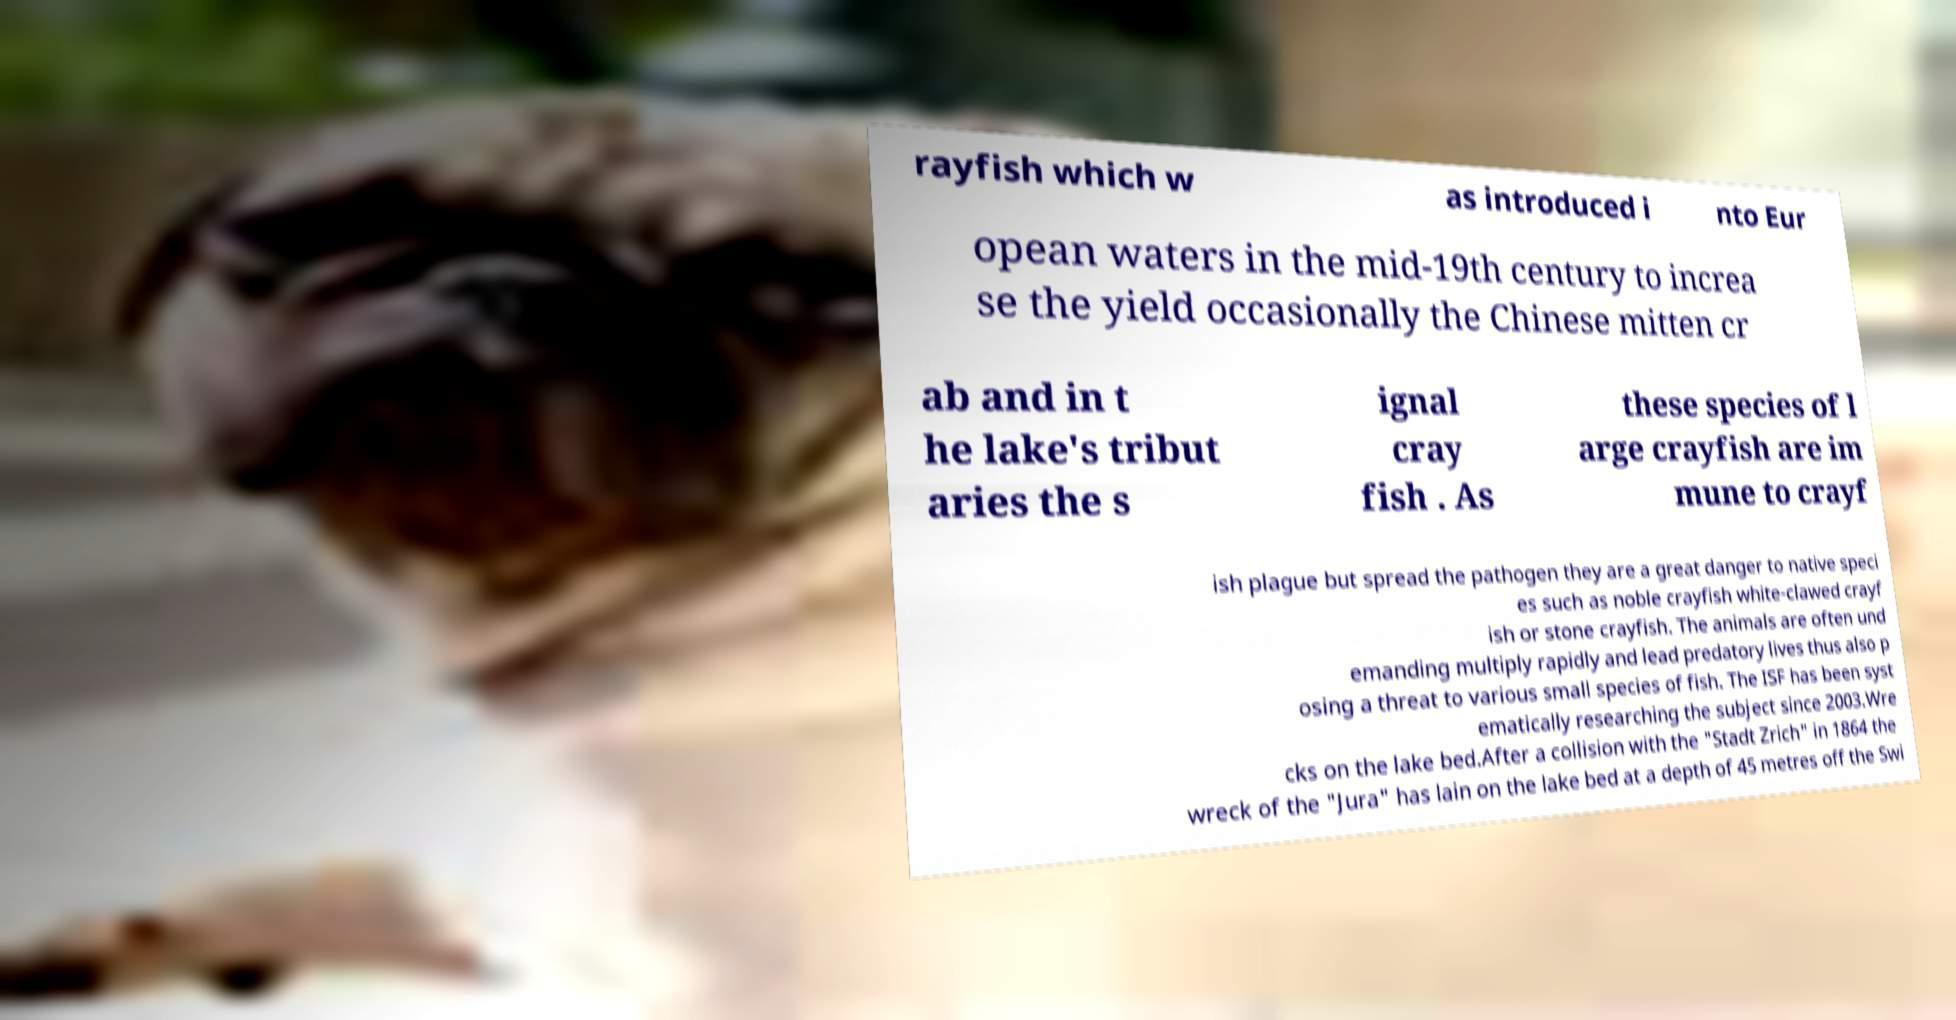Could you assist in decoding the text presented in this image and type it out clearly? rayfish which w as introduced i nto Eur opean waters in the mid-19th century to increa se the yield occasionally the Chinese mitten cr ab and in t he lake's tribut aries the s ignal cray fish . As these species of l arge crayfish are im mune to crayf ish plague but spread the pathogen they are a great danger to native speci es such as noble crayfish white-clawed crayf ish or stone crayfish. The animals are often und emanding multiply rapidly and lead predatory lives thus also p osing a threat to various small species of fish. The ISF has been syst ematically researching the subject since 2003.Wre cks on the lake bed.After a collision with the "Stadt Zrich" in 1864 the wreck of the "Jura" has lain on the lake bed at a depth of 45 metres off the Swi 